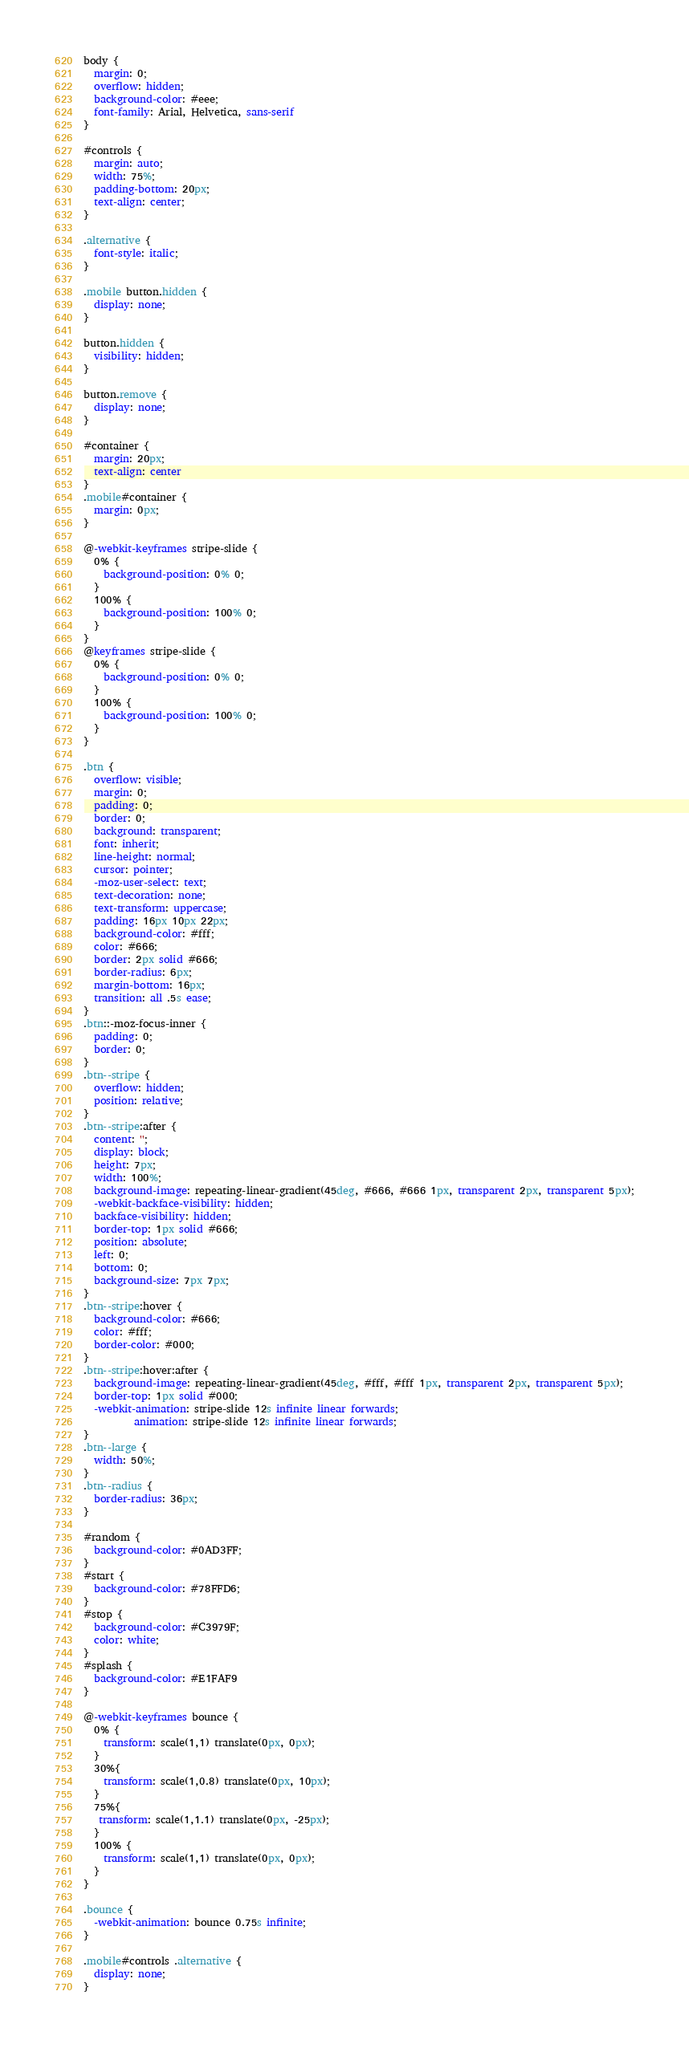Convert code to text. <code><loc_0><loc_0><loc_500><loc_500><_CSS_>body {
  margin: 0;
  overflow: hidden;
  background-color: #eee;
  font-family: Arial, Helvetica, sans-serif	
}

#controls {
  margin: auto;
  width: 75%;
  padding-bottom: 20px;
  text-align: center;
}

.alternative {
  font-style: italic;
}

.mobile button.hidden {
  display: none;
}

button.hidden {
  visibility: hidden;
}

button.remove {
  display: none;
}

#container {
  margin: 20px;
  text-align: center
}
.mobile#container {
  margin: 0px;
}

@-webkit-keyframes stripe-slide {
  0% {
    background-position: 0% 0;
  }
  100% {
    background-position: 100% 0;
  }
}
@keyframes stripe-slide {
  0% {
    background-position: 0% 0;
  }
  100% {
    background-position: 100% 0;
  }
}

.btn {
  overflow: visible;
  margin: 0;
  padding: 0;
  border: 0;
  background: transparent;
  font: inherit;
  line-height: normal;
  cursor: pointer;
  -moz-user-select: text;
  text-decoration: none;
  text-transform: uppercase;
  padding: 16px 10px 22px;
  background-color: #fff;
  color: #666;
  border: 2px solid #666;
  border-radius: 6px;
  margin-bottom: 16px;
  transition: all .5s ease;
}
.btn::-moz-focus-inner {
  padding: 0;
  border: 0;
}
.btn--stripe {
  overflow: hidden;
  position: relative;
}
.btn--stripe:after {
  content: '';
  display: block;
  height: 7px;
  width: 100%;
  background-image: repeating-linear-gradient(45deg, #666, #666 1px, transparent 2px, transparent 5px);
  -webkit-backface-visibility: hidden;
  backface-visibility: hidden;
  border-top: 1px solid #666;
  position: absolute;
  left: 0;
  bottom: 0;
  background-size: 7px 7px;
}
.btn--stripe:hover {
  background-color: #666;
  color: #fff;
  border-color: #000;
}
.btn--stripe:hover:after {
  background-image: repeating-linear-gradient(45deg, #fff, #fff 1px, transparent 2px, transparent 5px);
  border-top: 1px solid #000;
  -webkit-animation: stripe-slide 12s infinite linear forwards;
          animation: stripe-slide 12s infinite linear forwards;
}
.btn--large {
  width: 50%;
}
.btn--radius {
  border-radius: 36px;
}

#random {
  background-color: #0AD3FF;
}
#start {
  background-color: #78FFD6;
}
#stop {
  background-color: #C3979F;
  color: white;
}
#splash {
  background-color: #E1FAF9
}

@-webkit-keyframes bounce {
  0% {
    transform: scale(1,1) translate(0px, 0px);
  }
  30%{
    transform: scale(1,0.8) translate(0px, 10px);
  }
  75%{
   transform: scale(1,1.1) translate(0px, -25px);
  }
  100% {
    transform: scale(1,1) translate(0px, 0px);
  }
}

.bounce {
  -webkit-animation: bounce 0.75s infinite;
}

.mobile#controls .alternative {
  display: none;
}</code> 